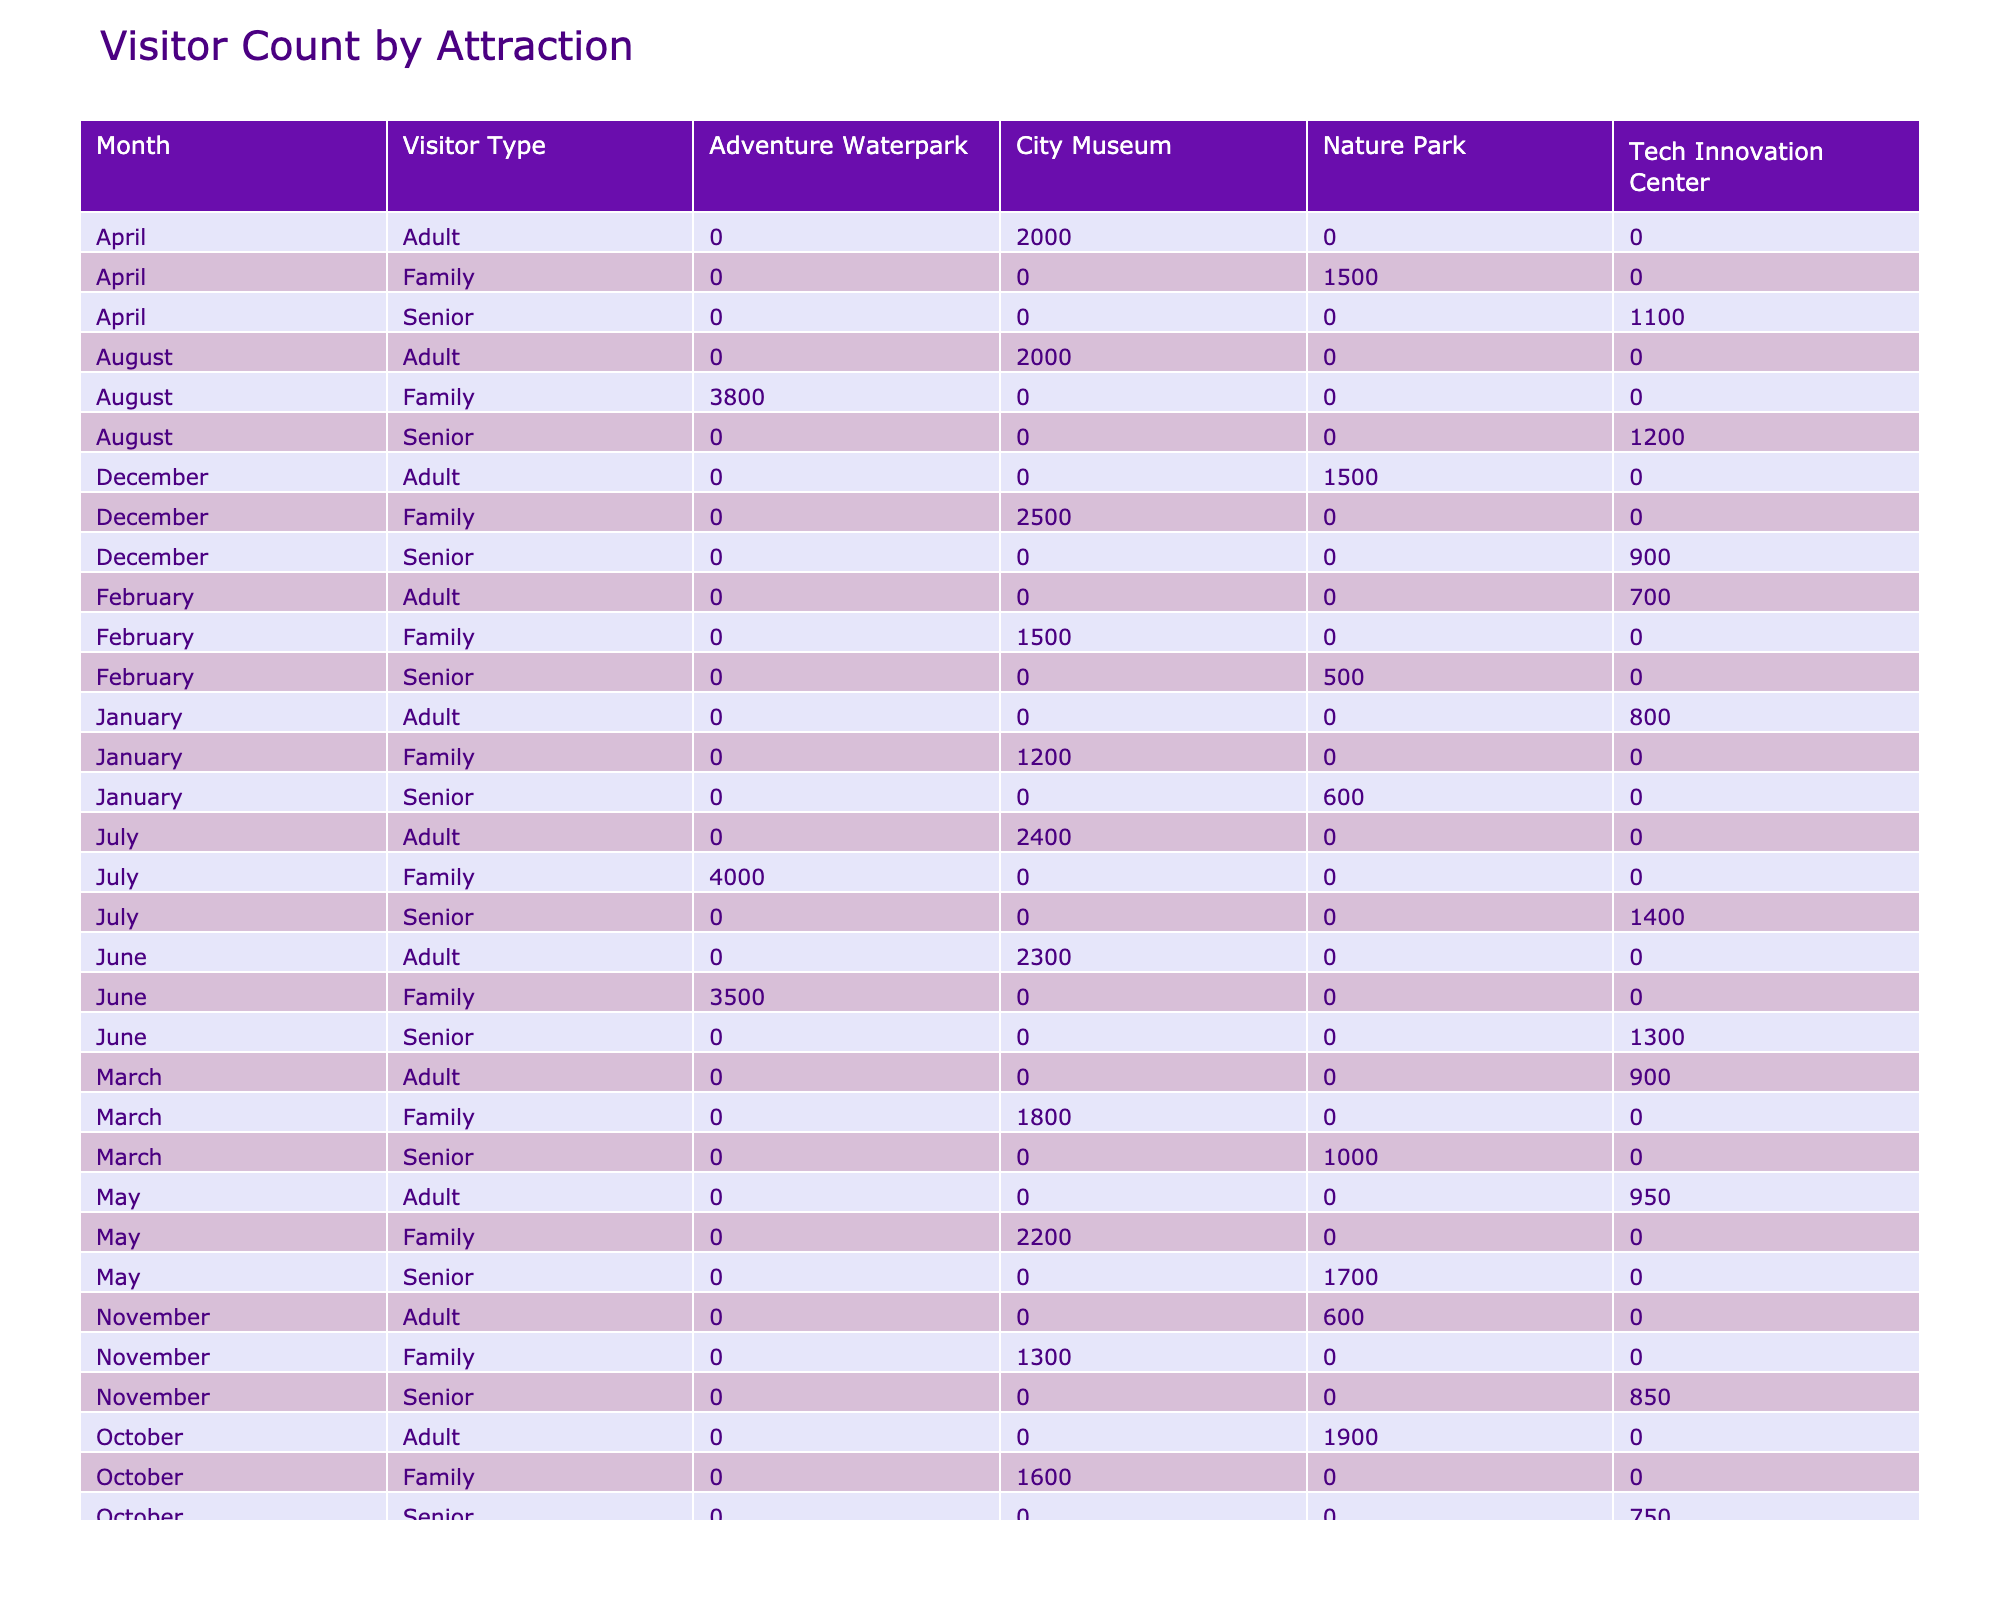What is the total visitor count for the City Museum in January? From the table, I can see that the City Museum had a visitor count of 1200 in January.
Answer: 1200 In which month did the Nature Park have the highest number of senior visitors? By looking at the data, the Nature Park had 1000 senior visitors in March, which is the highest count for that category across all months.
Answer: March What is the average visitor count for the Tech Innovation Center in the summer months (June, July, August)? The Tech Innovation Center had visitor counts of 1300 in June, 1400 in July, and 1200 in August. The average is (1300 + 1400 + 1200) / 3 = 1300.
Answer: 1300 Did the visitor count for the Adventure Waterpark increase every month from June to August? In June, the Adventure Waterpark had 3500 visitors, and in July, there were 4000 visitors, which does show an increase. However, in August, the count decreased to 3800, indicating that the count did not consistently increase.
Answer: No What is the percentage increase in visitor count for the City Museum from February to March? The City Museum had 1500 visitors in February and 1800 in March. The increase is 1800 - 1500 = 300. The percentage increase is (300 / 1500) * 100% = 20%.
Answer: 20% What type of visitor spent the most on average at the Tech Innovation Center in April? The average spend for seniors at the Tech Innovation Center in April is 28, while for adults it is 18. Therefore, seniors spent the most on average.
Answer: Seniors How many visitors did the City Museum attract in total during the last quarter of the year (October to December)? In October, the City Museum had 1600 visitors, in November 1300, and in December 2500, summing these values gives us 1600 + 1300 + 2500 = 5400.
Answer: 5400 Which attraction has the highest total visitor count across all months for family visitors? The Adventure Waterpark had family visitor counts of 3500 in June, 4000 in July, and 3800 in August, totaling 11300. The City Museum family visitors total 1200 + 1500 + 1800 + 2200 + 2400 + 1700 + 1600 + 1300 + 2500 = 11500. Thus, the Adventure Waterpark has the highest family visitor count.
Answer: Adventure Waterpark Is it true that the average spend for seniors is higher than for families at the Nature Park? The average spend for seniors at the Nature Park is 12 in February and 15 in March, while for families, it's 20 in April and 27 in May. Since 15 is less than 27, it is false that seniors spend more on average than families at the Nature Park.
Answer: No What was the most popular month for family visitors at the Adventure Waterpark? The Adventure Waterpark had its highest visitor count of 4000 in July, making it the most popular month for family visitors at that attraction.
Answer: July What is the total spend of all visitors at the Tech Innovation Center for seniors across all months? The Tech Innovation Center had senior visitors of 22 in April, 30 in July, 27 in August, 19 in September, 23 in October, and 20 in November, totaling 22 + 30 + 27 + 19 + 23 + 20 = 141.
Answer: 141 